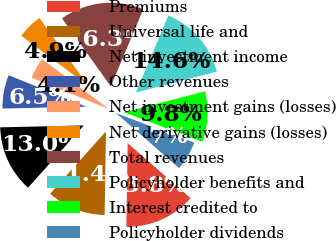Convert chart to OTSL. <chart><loc_0><loc_0><loc_500><loc_500><pie_chart><fcel>Premiums<fcel>Universal life and<fcel>Net investment income<fcel>Other revenues<fcel>Net investment gains (losses)<fcel>Net derivative gains (losses)<fcel>Total revenues<fcel>Policyholder benefits and<fcel>Interest credited to<fcel>Policyholder dividends<nl><fcel>13.82%<fcel>11.38%<fcel>13.01%<fcel>6.5%<fcel>4.07%<fcel>4.88%<fcel>16.26%<fcel>14.63%<fcel>9.76%<fcel>5.69%<nl></chart> 